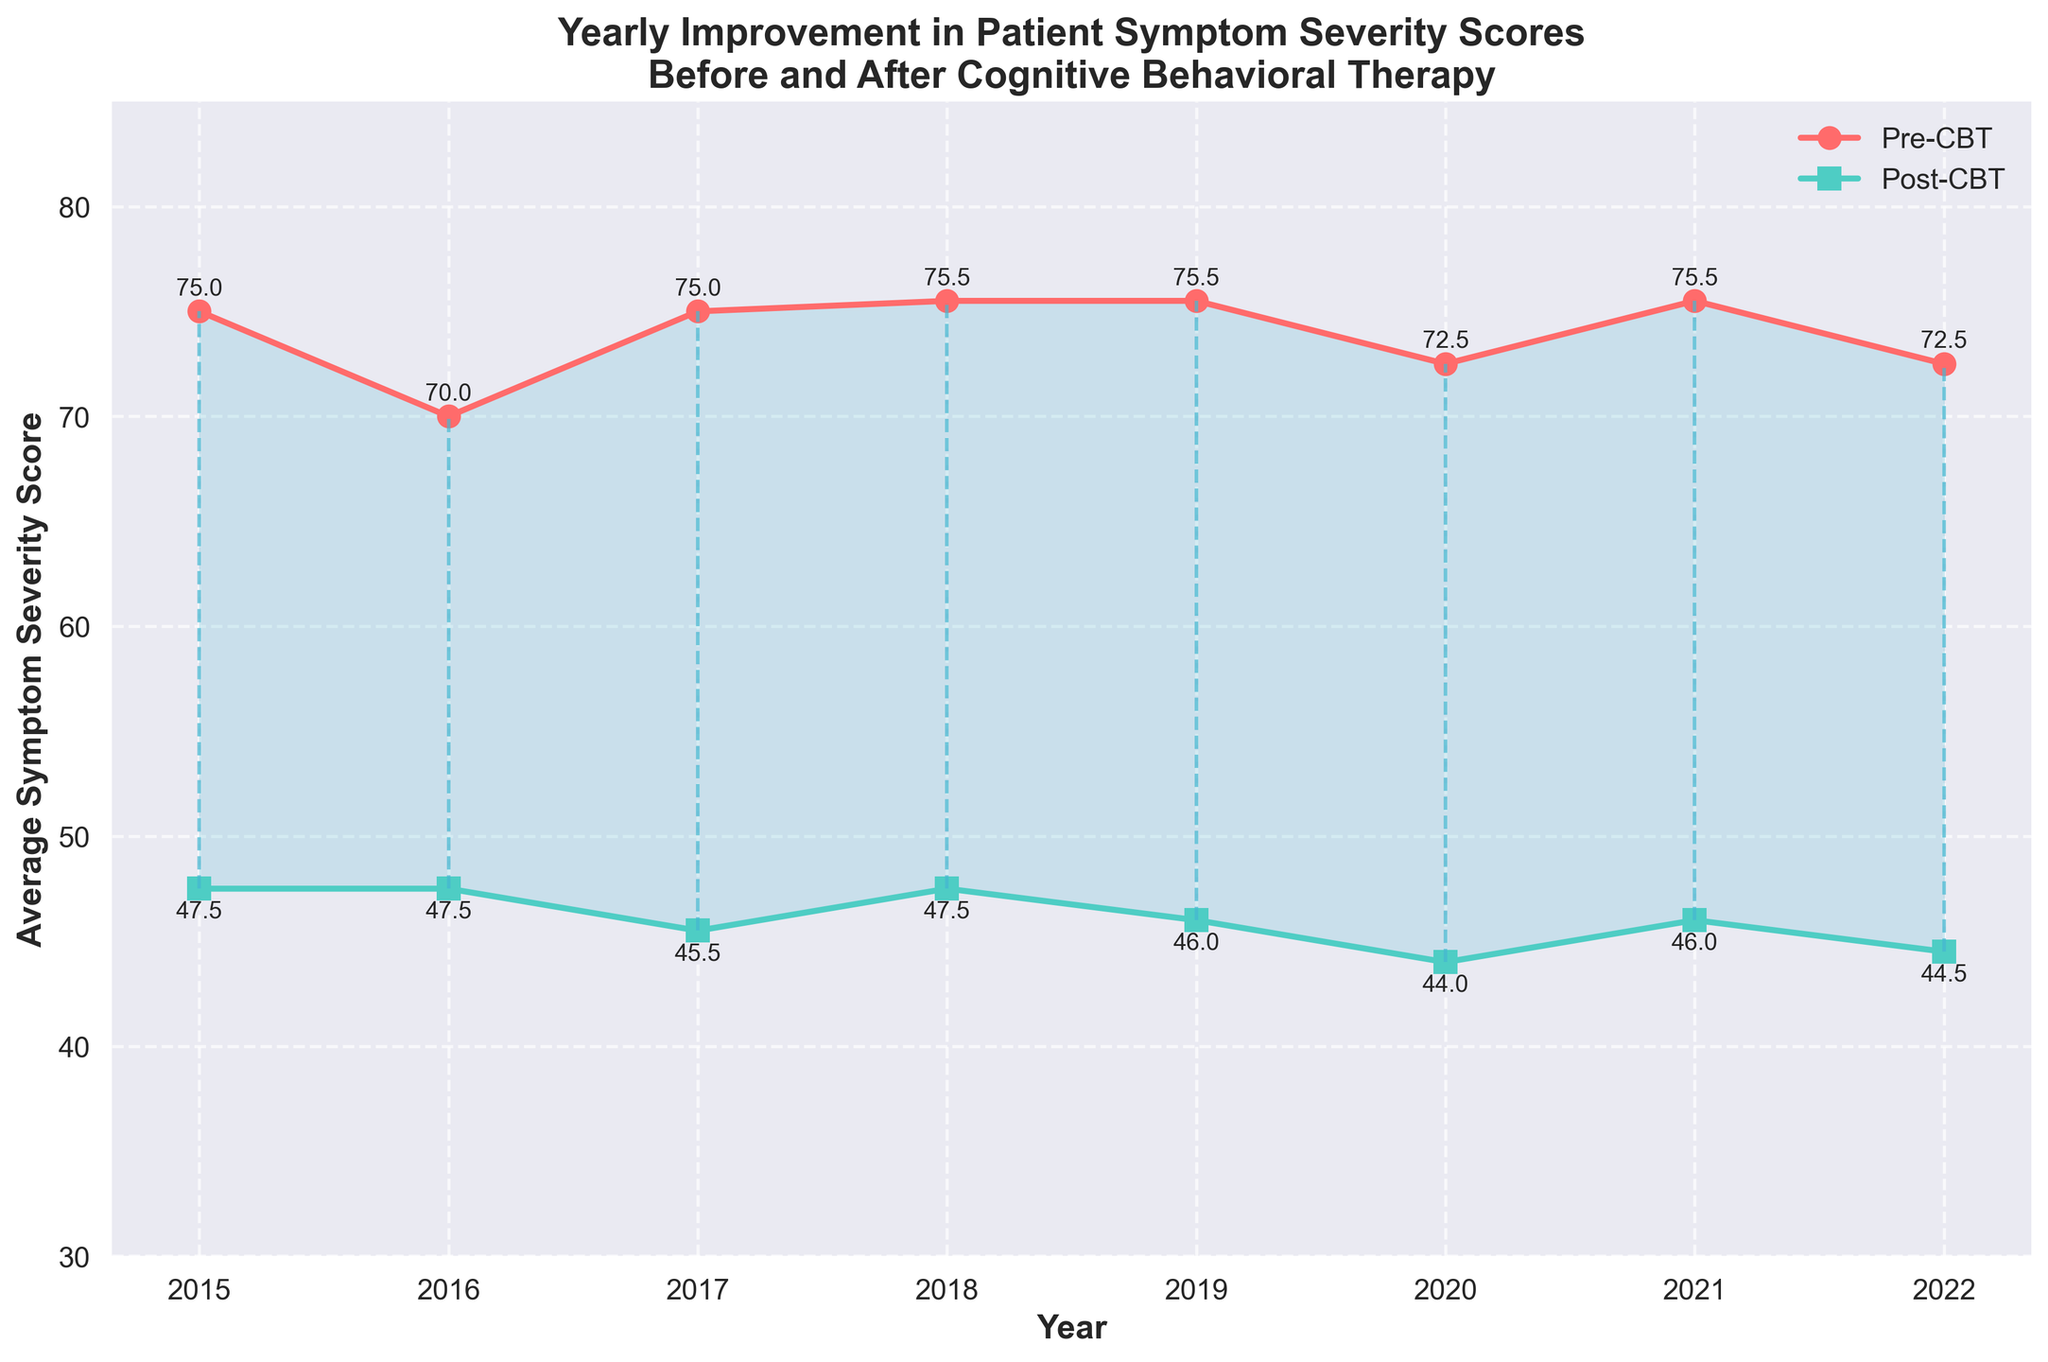What is the title of the figure? The title is the main text displayed at the top of the figure. It is usually a concise description of what the figure represents.
Answer: "Yearly Improvement in Patient Symptom Severity Scores Before and After Cognitive Behavioral Therapy" What are the axis labels? The axis labels are typically positioned along the axes of the plot. The x-axis label is at the bottom, and the y-axis label is on the left side.
Answer: "Year" and "Average Symptom Severity Score" Which year shows the highest average Pre-CBT symptom severity score? Look for the year with the highest plotted value on the line representing Pre-CBT scores.
Answer: 2017 How much did the average symptom severity score reduce after CBT in 2021? Identify the difference between the Pre-CBT and Post-CBT scores for 2021. The Pre-CBT score is 72, and the Post-CBT score is 44, so subtract the latter from the former.
Answer: 28 What is the overall trend of the Post-CBT scores over the years? Observe the general direction of the line representing Post-CBT scores from 2015 to 2022.
Answer: Downward trend Do the Pre-CBT scores ever decrease over the years? If so, between which years does this happen? Check the line representing Pre-CBT scores for any points where the value decreases from one year to the next.
Answer: Yes, from 2017 to 2018 Is there any year where the average Pre-CBT and Post-CBT scores are the closest to each other? Look for the smallest vertical line between the Pre-CBT and Post-CBT points on the plot.
Answer: 2017 How many markers are used for the Pre-CBT scores, and what is their shape? Count the number of data points plotted for Pre-CBT scores and describe their shape, which is indicated in the legend.
Answer: 8, circular shape Which year had the most significant improvement in symptom severity scores after CBT? Find the year where the vertical difference between Pre-CBT and Post-CBT scores is the largest.
Answer: 2017 How does the fill between the Pre-CBT and Post-CBT lines visually indicate the improvement in scores? The fill area between the two lines represents the difference or improvement in scores, shown in a shaded color.
Answer: It visually highlights the reduction in symptom severity scores after CBT 